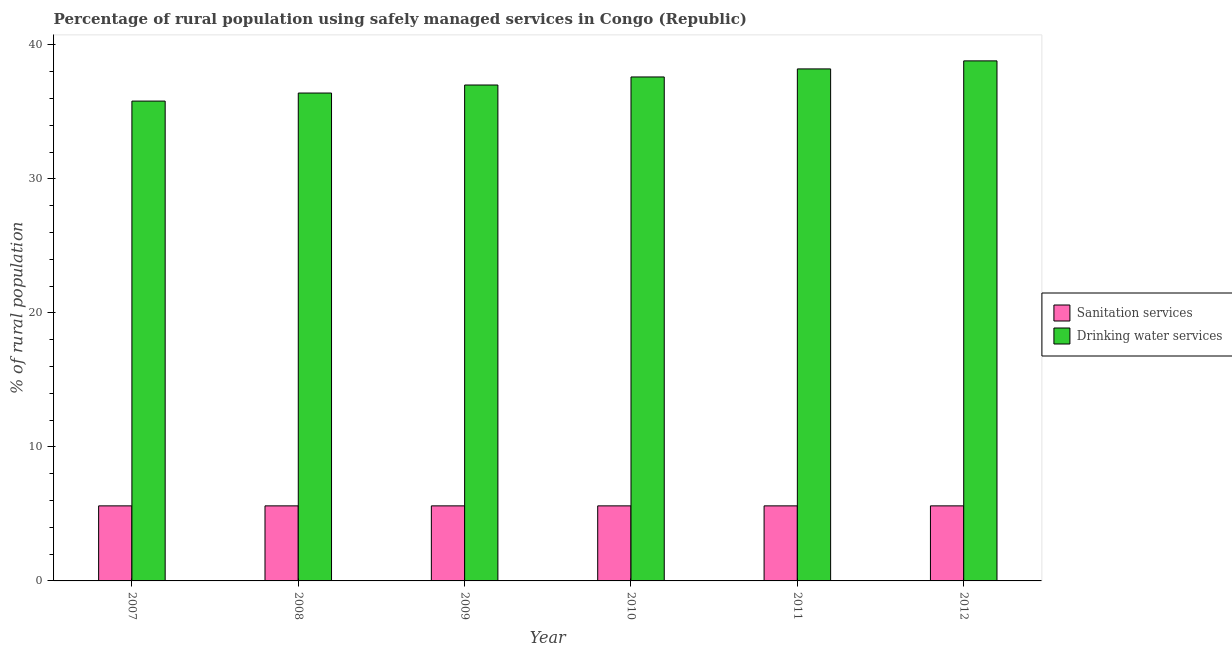How many different coloured bars are there?
Your response must be concise. 2. Are the number of bars per tick equal to the number of legend labels?
Offer a terse response. Yes. How many bars are there on the 2nd tick from the left?
Ensure brevity in your answer.  2. In how many cases, is the number of bars for a given year not equal to the number of legend labels?
Offer a very short reply. 0. Across all years, what is the maximum percentage of rural population who used drinking water services?
Your answer should be compact. 38.8. Across all years, what is the minimum percentage of rural population who used drinking water services?
Provide a succinct answer. 35.8. In which year was the percentage of rural population who used drinking water services maximum?
Keep it short and to the point. 2012. In which year was the percentage of rural population who used sanitation services minimum?
Provide a short and direct response. 2007. What is the total percentage of rural population who used sanitation services in the graph?
Offer a terse response. 33.6. What is the difference between the percentage of rural population who used drinking water services in 2008 and that in 2009?
Make the answer very short. -0.6. What is the difference between the percentage of rural population who used drinking water services in 2012 and the percentage of rural population who used sanitation services in 2010?
Provide a succinct answer. 1.2. What is the average percentage of rural population who used drinking water services per year?
Ensure brevity in your answer.  37.3. In the year 2011, what is the difference between the percentage of rural population who used sanitation services and percentage of rural population who used drinking water services?
Offer a very short reply. 0. In how many years, is the percentage of rural population who used drinking water services greater than 8 %?
Ensure brevity in your answer.  6. What is the ratio of the percentage of rural population who used sanitation services in 2007 to that in 2009?
Provide a succinct answer. 1. What is the difference between the highest and the second highest percentage of rural population who used drinking water services?
Give a very brief answer. 0.6. What does the 1st bar from the left in 2009 represents?
Make the answer very short. Sanitation services. What does the 1st bar from the right in 2012 represents?
Make the answer very short. Drinking water services. How many bars are there?
Keep it short and to the point. 12. How many years are there in the graph?
Provide a short and direct response. 6. What is the difference between two consecutive major ticks on the Y-axis?
Your response must be concise. 10. Does the graph contain grids?
Ensure brevity in your answer.  No. Where does the legend appear in the graph?
Your answer should be compact. Center right. How many legend labels are there?
Provide a short and direct response. 2. What is the title of the graph?
Give a very brief answer. Percentage of rural population using safely managed services in Congo (Republic). Does "Fertility rate" appear as one of the legend labels in the graph?
Ensure brevity in your answer.  No. What is the label or title of the X-axis?
Keep it short and to the point. Year. What is the label or title of the Y-axis?
Make the answer very short. % of rural population. What is the % of rural population in Drinking water services in 2007?
Make the answer very short. 35.8. What is the % of rural population of Drinking water services in 2008?
Give a very brief answer. 36.4. What is the % of rural population of Sanitation services in 2009?
Your answer should be very brief. 5.6. What is the % of rural population in Drinking water services in 2009?
Keep it short and to the point. 37. What is the % of rural population of Sanitation services in 2010?
Give a very brief answer. 5.6. What is the % of rural population in Drinking water services in 2010?
Your response must be concise. 37.6. What is the % of rural population in Drinking water services in 2011?
Ensure brevity in your answer.  38.2. What is the % of rural population in Sanitation services in 2012?
Your response must be concise. 5.6. What is the % of rural population of Drinking water services in 2012?
Your answer should be compact. 38.8. Across all years, what is the maximum % of rural population in Drinking water services?
Keep it short and to the point. 38.8. Across all years, what is the minimum % of rural population in Drinking water services?
Offer a terse response. 35.8. What is the total % of rural population in Sanitation services in the graph?
Give a very brief answer. 33.6. What is the total % of rural population in Drinking water services in the graph?
Your response must be concise. 223.8. What is the difference between the % of rural population of Sanitation services in 2007 and that in 2009?
Provide a succinct answer. 0. What is the difference between the % of rural population in Sanitation services in 2007 and that in 2010?
Offer a very short reply. 0. What is the difference between the % of rural population of Drinking water services in 2007 and that in 2010?
Offer a terse response. -1.8. What is the difference between the % of rural population of Drinking water services in 2007 and that in 2011?
Offer a very short reply. -2.4. What is the difference between the % of rural population of Sanitation services in 2008 and that in 2010?
Provide a succinct answer. 0. What is the difference between the % of rural population in Sanitation services in 2008 and that in 2012?
Ensure brevity in your answer.  0. What is the difference between the % of rural population of Drinking water services in 2009 and that in 2011?
Your response must be concise. -1.2. What is the difference between the % of rural population in Sanitation services in 2009 and that in 2012?
Make the answer very short. 0. What is the difference between the % of rural population of Drinking water services in 2010 and that in 2011?
Your answer should be compact. -0.6. What is the difference between the % of rural population in Sanitation services in 2010 and that in 2012?
Offer a terse response. 0. What is the difference between the % of rural population in Sanitation services in 2011 and that in 2012?
Give a very brief answer. 0. What is the difference between the % of rural population in Drinking water services in 2011 and that in 2012?
Offer a terse response. -0.6. What is the difference between the % of rural population in Sanitation services in 2007 and the % of rural population in Drinking water services in 2008?
Your response must be concise. -30.8. What is the difference between the % of rural population of Sanitation services in 2007 and the % of rural population of Drinking water services in 2009?
Keep it short and to the point. -31.4. What is the difference between the % of rural population in Sanitation services in 2007 and the % of rural population in Drinking water services in 2010?
Give a very brief answer. -32. What is the difference between the % of rural population of Sanitation services in 2007 and the % of rural population of Drinking water services in 2011?
Offer a very short reply. -32.6. What is the difference between the % of rural population of Sanitation services in 2007 and the % of rural population of Drinking water services in 2012?
Your response must be concise. -33.2. What is the difference between the % of rural population in Sanitation services in 2008 and the % of rural population in Drinking water services in 2009?
Ensure brevity in your answer.  -31.4. What is the difference between the % of rural population in Sanitation services in 2008 and the % of rural population in Drinking water services in 2010?
Ensure brevity in your answer.  -32. What is the difference between the % of rural population in Sanitation services in 2008 and the % of rural population in Drinking water services in 2011?
Keep it short and to the point. -32.6. What is the difference between the % of rural population in Sanitation services in 2008 and the % of rural population in Drinking water services in 2012?
Make the answer very short. -33.2. What is the difference between the % of rural population in Sanitation services in 2009 and the % of rural population in Drinking water services in 2010?
Your answer should be very brief. -32. What is the difference between the % of rural population of Sanitation services in 2009 and the % of rural population of Drinking water services in 2011?
Provide a succinct answer. -32.6. What is the difference between the % of rural population of Sanitation services in 2009 and the % of rural population of Drinking water services in 2012?
Give a very brief answer. -33.2. What is the difference between the % of rural population in Sanitation services in 2010 and the % of rural population in Drinking water services in 2011?
Make the answer very short. -32.6. What is the difference between the % of rural population in Sanitation services in 2010 and the % of rural population in Drinking water services in 2012?
Keep it short and to the point. -33.2. What is the difference between the % of rural population in Sanitation services in 2011 and the % of rural population in Drinking water services in 2012?
Your answer should be very brief. -33.2. What is the average % of rural population of Drinking water services per year?
Your response must be concise. 37.3. In the year 2007, what is the difference between the % of rural population in Sanitation services and % of rural population in Drinking water services?
Your answer should be compact. -30.2. In the year 2008, what is the difference between the % of rural population of Sanitation services and % of rural population of Drinking water services?
Your answer should be very brief. -30.8. In the year 2009, what is the difference between the % of rural population of Sanitation services and % of rural population of Drinking water services?
Your answer should be compact. -31.4. In the year 2010, what is the difference between the % of rural population in Sanitation services and % of rural population in Drinking water services?
Offer a terse response. -32. In the year 2011, what is the difference between the % of rural population in Sanitation services and % of rural population in Drinking water services?
Your answer should be very brief. -32.6. In the year 2012, what is the difference between the % of rural population in Sanitation services and % of rural population in Drinking water services?
Ensure brevity in your answer.  -33.2. What is the ratio of the % of rural population of Sanitation services in 2007 to that in 2008?
Ensure brevity in your answer.  1. What is the ratio of the % of rural population of Drinking water services in 2007 to that in 2008?
Make the answer very short. 0.98. What is the ratio of the % of rural population of Drinking water services in 2007 to that in 2009?
Provide a succinct answer. 0.97. What is the ratio of the % of rural population in Drinking water services in 2007 to that in 2010?
Give a very brief answer. 0.95. What is the ratio of the % of rural population in Sanitation services in 2007 to that in 2011?
Give a very brief answer. 1. What is the ratio of the % of rural population of Drinking water services in 2007 to that in 2011?
Offer a terse response. 0.94. What is the ratio of the % of rural population of Sanitation services in 2007 to that in 2012?
Your response must be concise. 1. What is the ratio of the % of rural population of Drinking water services in 2007 to that in 2012?
Your answer should be compact. 0.92. What is the ratio of the % of rural population in Sanitation services in 2008 to that in 2009?
Your response must be concise. 1. What is the ratio of the % of rural population in Drinking water services in 2008 to that in 2009?
Offer a terse response. 0.98. What is the ratio of the % of rural population of Drinking water services in 2008 to that in 2010?
Ensure brevity in your answer.  0.97. What is the ratio of the % of rural population in Sanitation services in 2008 to that in 2011?
Ensure brevity in your answer.  1. What is the ratio of the % of rural population of Drinking water services in 2008 to that in 2011?
Offer a very short reply. 0.95. What is the ratio of the % of rural population in Drinking water services in 2008 to that in 2012?
Your response must be concise. 0.94. What is the ratio of the % of rural population of Drinking water services in 2009 to that in 2010?
Offer a terse response. 0.98. What is the ratio of the % of rural population in Drinking water services in 2009 to that in 2011?
Your answer should be compact. 0.97. What is the ratio of the % of rural population in Drinking water services in 2009 to that in 2012?
Your answer should be very brief. 0.95. What is the ratio of the % of rural population in Sanitation services in 2010 to that in 2011?
Your response must be concise. 1. What is the ratio of the % of rural population in Drinking water services in 2010 to that in 2011?
Keep it short and to the point. 0.98. What is the ratio of the % of rural population in Drinking water services in 2010 to that in 2012?
Give a very brief answer. 0.97. What is the ratio of the % of rural population in Drinking water services in 2011 to that in 2012?
Offer a very short reply. 0.98. What is the difference between the highest and the second highest % of rural population in Drinking water services?
Provide a short and direct response. 0.6. 